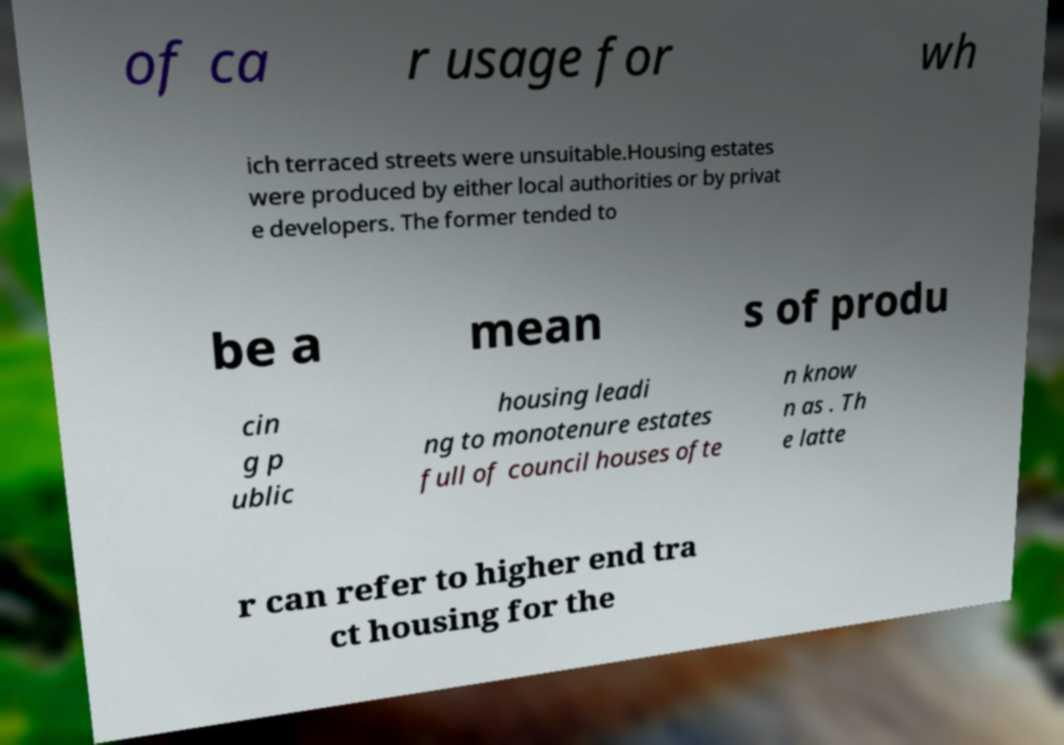Please read and relay the text visible in this image. What does it say? of ca r usage for wh ich terraced streets were unsuitable.Housing estates were produced by either local authorities or by privat e developers. The former tended to be a mean s of produ cin g p ublic housing leadi ng to monotenure estates full of council houses ofte n know n as . Th e latte r can refer to higher end tra ct housing for the 